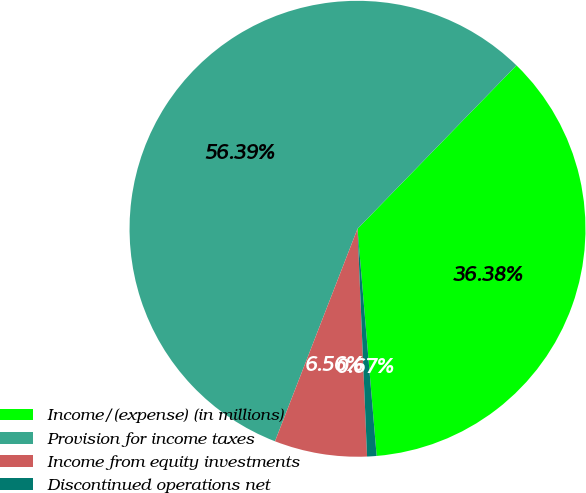Convert chart to OTSL. <chart><loc_0><loc_0><loc_500><loc_500><pie_chart><fcel>Income/(expense) (in millions)<fcel>Provision for income taxes<fcel>Income from equity investments<fcel>Discontinued operations net<nl><fcel>36.38%<fcel>56.38%<fcel>6.56%<fcel>0.67%<nl></chart> 